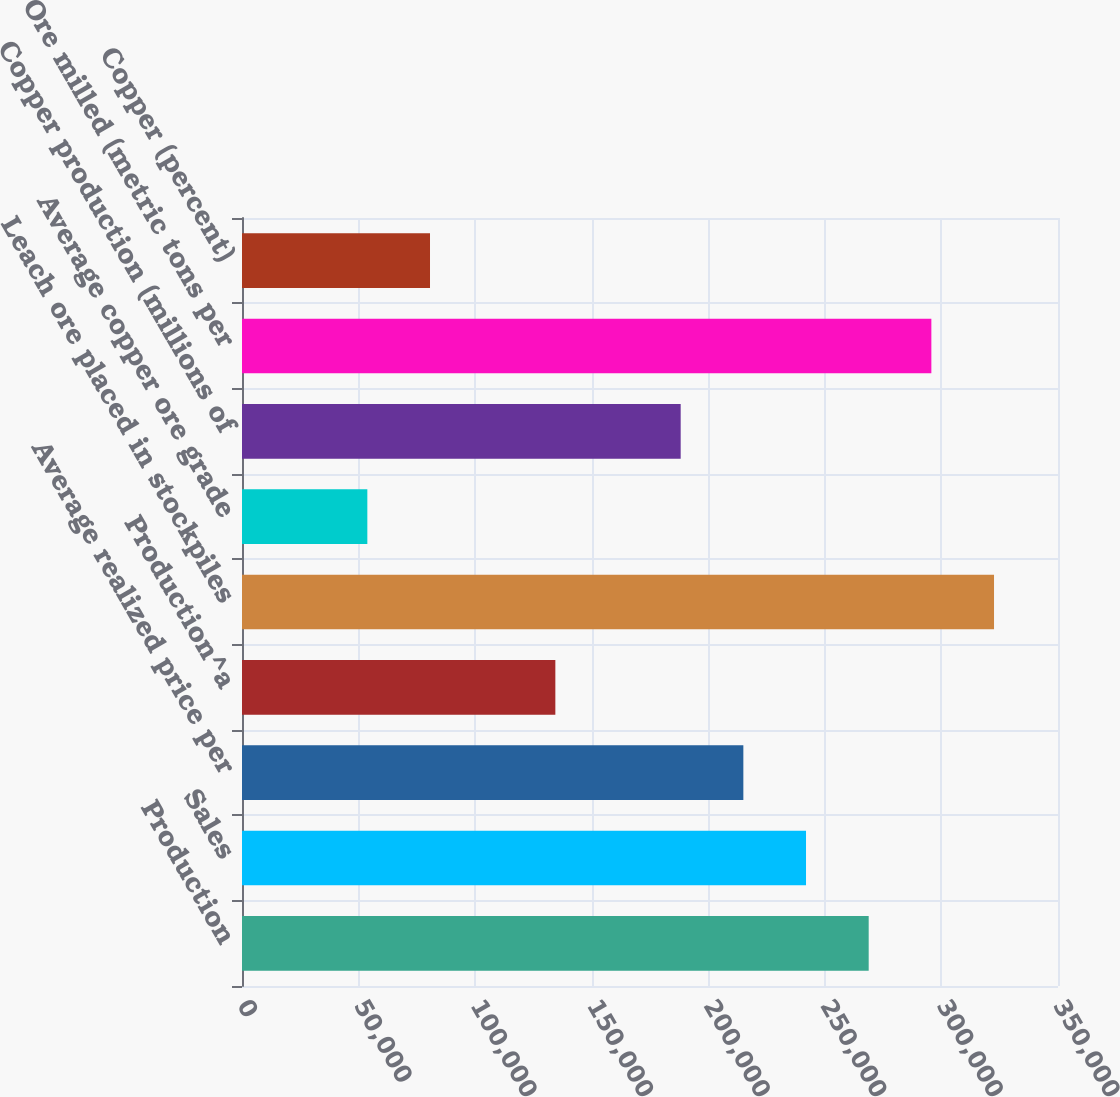Convert chart to OTSL. <chart><loc_0><loc_0><loc_500><loc_500><bar_chart><fcel>Production<fcel>Sales<fcel>Average realized price per<fcel>Production^a<fcel>Leach ore placed in stockpiles<fcel>Average copper ore grade<fcel>Copper production (millions of<fcel>Ore milled (metric tons per<fcel>Copper (percent)<nl><fcel>268800<fcel>241920<fcel>215040<fcel>134400<fcel>322560<fcel>53760<fcel>188160<fcel>295680<fcel>80640<nl></chart> 